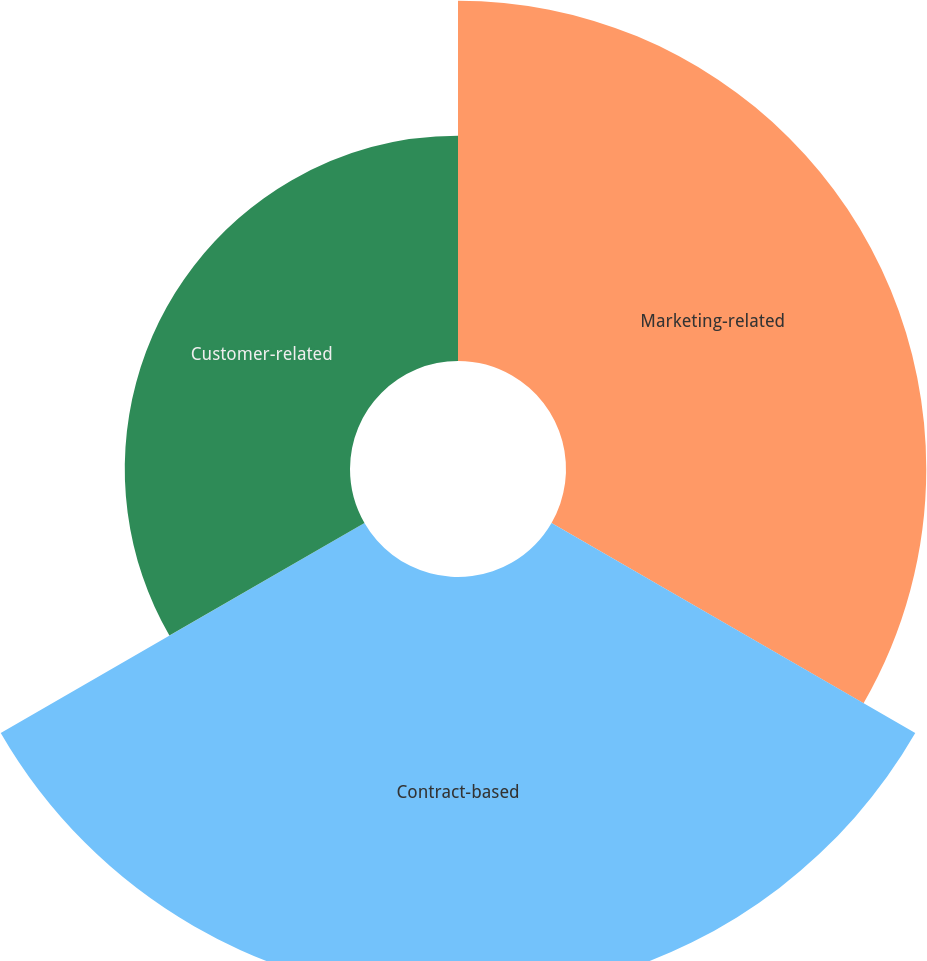Convert chart to OTSL. <chart><loc_0><loc_0><loc_500><loc_500><pie_chart><fcel>Marketing-related<fcel>Contract-based<fcel>Customer-related<nl><fcel>35.83%<fcel>41.77%<fcel>22.4%<nl></chart> 